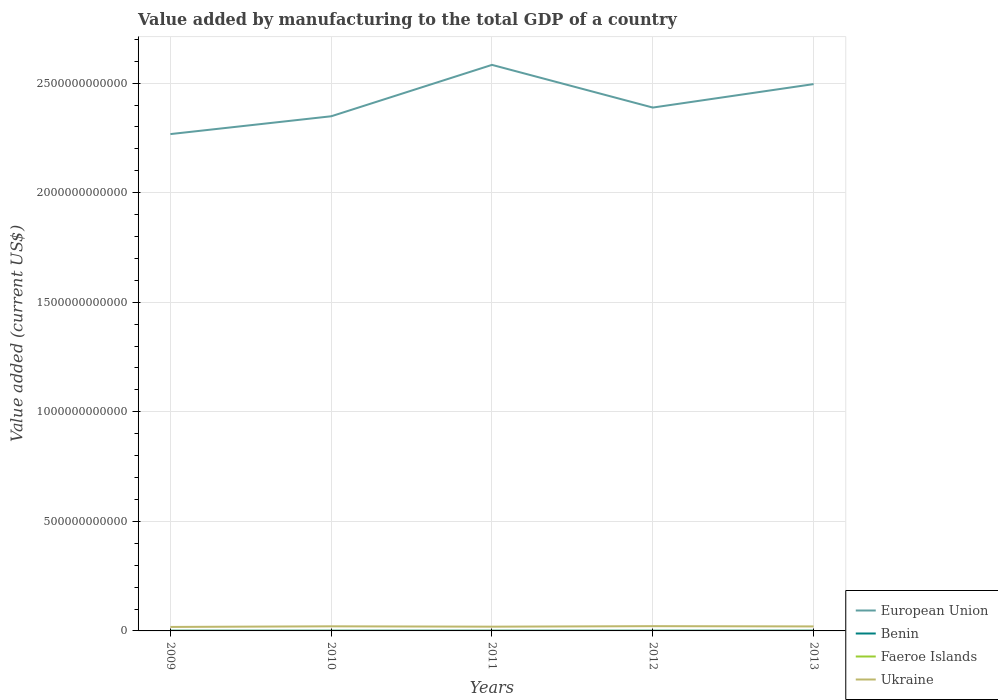How many different coloured lines are there?
Provide a succinct answer. 4. Does the line corresponding to Ukraine intersect with the line corresponding to European Union?
Provide a short and direct response. No. Across all years, what is the maximum value added by manufacturing to the total GDP in European Union?
Offer a terse response. 2.27e+12. What is the total value added by manufacturing to the total GDP in Ukraine in the graph?
Your response must be concise. -2.85e+09. What is the difference between the highest and the second highest value added by manufacturing to the total GDP in Ukraine?
Provide a short and direct response. 3.55e+09. What is the difference between the highest and the lowest value added by manufacturing to the total GDP in European Union?
Give a very brief answer. 2. Is the value added by manufacturing to the total GDP in Faeroe Islands strictly greater than the value added by manufacturing to the total GDP in Ukraine over the years?
Your response must be concise. Yes. How many lines are there?
Your answer should be compact. 4. What is the difference between two consecutive major ticks on the Y-axis?
Provide a short and direct response. 5.00e+11. Are the values on the major ticks of Y-axis written in scientific E-notation?
Make the answer very short. No. Does the graph contain grids?
Provide a succinct answer. Yes. How many legend labels are there?
Your answer should be compact. 4. How are the legend labels stacked?
Your answer should be very brief. Vertical. What is the title of the graph?
Make the answer very short. Value added by manufacturing to the total GDP of a country. Does "Congo (Democratic)" appear as one of the legend labels in the graph?
Give a very brief answer. No. What is the label or title of the Y-axis?
Keep it short and to the point. Value added (current US$). What is the Value added (current US$) in European Union in 2009?
Your answer should be compact. 2.27e+12. What is the Value added (current US$) in Benin in 2009?
Make the answer very short. 1.02e+09. What is the Value added (current US$) in Faeroe Islands in 2009?
Your response must be concise. 1.36e+08. What is the Value added (current US$) of Ukraine in 2009?
Your answer should be compact. 1.82e+1. What is the Value added (current US$) in European Union in 2010?
Provide a short and direct response. 2.35e+12. What is the Value added (current US$) in Benin in 2010?
Provide a short and direct response. 9.63e+08. What is the Value added (current US$) in Faeroe Islands in 2010?
Give a very brief answer. 1.35e+08. What is the Value added (current US$) of Ukraine in 2010?
Provide a short and direct response. 2.11e+1. What is the Value added (current US$) in European Union in 2011?
Your answer should be compact. 2.58e+12. What is the Value added (current US$) in Benin in 2011?
Provide a short and direct response. 1.04e+09. What is the Value added (current US$) in Faeroe Islands in 2011?
Provide a succinct answer. 1.44e+08. What is the Value added (current US$) in Ukraine in 2011?
Your answer should be very brief. 1.94e+1. What is the Value added (current US$) in European Union in 2012?
Keep it short and to the point. 2.39e+12. What is the Value added (current US$) in Benin in 2012?
Provide a short and direct response. 1.03e+09. What is the Value added (current US$) in Faeroe Islands in 2012?
Provide a succinct answer. 1.42e+08. What is the Value added (current US$) in Ukraine in 2012?
Offer a terse response. 2.18e+1. What is the Value added (current US$) in European Union in 2013?
Provide a short and direct response. 2.50e+12. What is the Value added (current US$) in Benin in 2013?
Offer a very short reply. 1.17e+09. What is the Value added (current US$) of Faeroe Islands in 2013?
Provide a short and direct response. 1.54e+08. What is the Value added (current US$) in Ukraine in 2013?
Provide a succinct answer. 2.06e+1. Across all years, what is the maximum Value added (current US$) of European Union?
Your answer should be compact. 2.58e+12. Across all years, what is the maximum Value added (current US$) in Benin?
Offer a terse response. 1.17e+09. Across all years, what is the maximum Value added (current US$) of Faeroe Islands?
Your response must be concise. 1.54e+08. Across all years, what is the maximum Value added (current US$) of Ukraine?
Your response must be concise. 2.18e+1. Across all years, what is the minimum Value added (current US$) of European Union?
Your answer should be very brief. 2.27e+12. Across all years, what is the minimum Value added (current US$) of Benin?
Your answer should be compact. 9.63e+08. Across all years, what is the minimum Value added (current US$) of Faeroe Islands?
Offer a terse response. 1.35e+08. Across all years, what is the minimum Value added (current US$) of Ukraine?
Provide a succinct answer. 1.82e+1. What is the total Value added (current US$) of European Union in the graph?
Your answer should be compact. 1.21e+13. What is the total Value added (current US$) in Benin in the graph?
Provide a succinct answer. 5.23e+09. What is the total Value added (current US$) in Faeroe Islands in the graph?
Offer a very short reply. 7.11e+08. What is the total Value added (current US$) in Ukraine in the graph?
Your answer should be very brief. 1.01e+11. What is the difference between the Value added (current US$) of European Union in 2009 and that in 2010?
Make the answer very short. -8.13e+1. What is the difference between the Value added (current US$) of Benin in 2009 and that in 2010?
Give a very brief answer. 6.15e+07. What is the difference between the Value added (current US$) in Faeroe Islands in 2009 and that in 2010?
Offer a terse response. 1.40e+06. What is the difference between the Value added (current US$) in Ukraine in 2009 and that in 2010?
Your response must be concise. -2.85e+09. What is the difference between the Value added (current US$) of European Union in 2009 and that in 2011?
Ensure brevity in your answer.  -3.16e+11. What is the difference between the Value added (current US$) of Benin in 2009 and that in 2011?
Ensure brevity in your answer.  -1.53e+07. What is the difference between the Value added (current US$) of Faeroe Islands in 2009 and that in 2011?
Give a very brief answer. -7.25e+06. What is the difference between the Value added (current US$) of Ukraine in 2009 and that in 2011?
Provide a short and direct response. -1.20e+09. What is the difference between the Value added (current US$) of European Union in 2009 and that in 2012?
Keep it short and to the point. -1.21e+11. What is the difference between the Value added (current US$) in Benin in 2009 and that in 2012?
Your answer should be very brief. -4.08e+05. What is the difference between the Value added (current US$) of Faeroe Islands in 2009 and that in 2012?
Your answer should be very brief. -6.07e+06. What is the difference between the Value added (current US$) in Ukraine in 2009 and that in 2012?
Give a very brief answer. -3.55e+09. What is the difference between the Value added (current US$) of European Union in 2009 and that in 2013?
Your response must be concise. -2.28e+11. What is the difference between the Value added (current US$) of Benin in 2009 and that in 2013?
Provide a short and direct response. -1.48e+08. What is the difference between the Value added (current US$) in Faeroe Islands in 2009 and that in 2013?
Your answer should be very brief. -1.73e+07. What is the difference between the Value added (current US$) of Ukraine in 2009 and that in 2013?
Give a very brief answer. -2.36e+09. What is the difference between the Value added (current US$) of European Union in 2010 and that in 2011?
Give a very brief answer. -2.35e+11. What is the difference between the Value added (current US$) of Benin in 2010 and that in 2011?
Ensure brevity in your answer.  -7.68e+07. What is the difference between the Value added (current US$) of Faeroe Islands in 2010 and that in 2011?
Offer a very short reply. -8.65e+06. What is the difference between the Value added (current US$) in Ukraine in 2010 and that in 2011?
Ensure brevity in your answer.  1.65e+09. What is the difference between the Value added (current US$) of European Union in 2010 and that in 2012?
Make the answer very short. -3.98e+1. What is the difference between the Value added (current US$) of Benin in 2010 and that in 2012?
Keep it short and to the point. -6.19e+07. What is the difference between the Value added (current US$) of Faeroe Islands in 2010 and that in 2012?
Provide a succinct answer. -7.47e+06. What is the difference between the Value added (current US$) of Ukraine in 2010 and that in 2012?
Keep it short and to the point. -7.00e+08. What is the difference between the Value added (current US$) in European Union in 2010 and that in 2013?
Offer a very short reply. -1.47e+11. What is the difference between the Value added (current US$) in Benin in 2010 and that in 2013?
Provide a short and direct response. -2.10e+08. What is the difference between the Value added (current US$) of Faeroe Islands in 2010 and that in 2013?
Offer a terse response. -1.87e+07. What is the difference between the Value added (current US$) of Ukraine in 2010 and that in 2013?
Offer a terse response. 4.96e+08. What is the difference between the Value added (current US$) of European Union in 2011 and that in 2012?
Provide a short and direct response. 1.95e+11. What is the difference between the Value added (current US$) in Benin in 2011 and that in 2012?
Your answer should be compact. 1.49e+07. What is the difference between the Value added (current US$) of Faeroe Islands in 2011 and that in 2012?
Offer a terse response. 1.18e+06. What is the difference between the Value added (current US$) of Ukraine in 2011 and that in 2012?
Offer a very short reply. -2.35e+09. What is the difference between the Value added (current US$) in European Union in 2011 and that in 2013?
Your answer should be very brief. 8.77e+1. What is the difference between the Value added (current US$) of Benin in 2011 and that in 2013?
Offer a terse response. -1.33e+08. What is the difference between the Value added (current US$) in Faeroe Islands in 2011 and that in 2013?
Your answer should be very brief. -1.00e+07. What is the difference between the Value added (current US$) in Ukraine in 2011 and that in 2013?
Your answer should be compact. -1.15e+09. What is the difference between the Value added (current US$) in European Union in 2012 and that in 2013?
Make the answer very short. -1.07e+11. What is the difference between the Value added (current US$) of Benin in 2012 and that in 2013?
Make the answer very short. -1.48e+08. What is the difference between the Value added (current US$) of Faeroe Islands in 2012 and that in 2013?
Provide a succinct answer. -1.12e+07. What is the difference between the Value added (current US$) of Ukraine in 2012 and that in 2013?
Give a very brief answer. 1.20e+09. What is the difference between the Value added (current US$) in European Union in 2009 and the Value added (current US$) in Benin in 2010?
Make the answer very short. 2.27e+12. What is the difference between the Value added (current US$) in European Union in 2009 and the Value added (current US$) in Faeroe Islands in 2010?
Provide a succinct answer. 2.27e+12. What is the difference between the Value added (current US$) of European Union in 2009 and the Value added (current US$) of Ukraine in 2010?
Give a very brief answer. 2.25e+12. What is the difference between the Value added (current US$) of Benin in 2009 and the Value added (current US$) of Faeroe Islands in 2010?
Ensure brevity in your answer.  8.90e+08. What is the difference between the Value added (current US$) of Benin in 2009 and the Value added (current US$) of Ukraine in 2010?
Provide a short and direct response. -2.00e+1. What is the difference between the Value added (current US$) in Faeroe Islands in 2009 and the Value added (current US$) in Ukraine in 2010?
Keep it short and to the point. -2.09e+1. What is the difference between the Value added (current US$) in European Union in 2009 and the Value added (current US$) in Benin in 2011?
Offer a terse response. 2.27e+12. What is the difference between the Value added (current US$) in European Union in 2009 and the Value added (current US$) in Faeroe Islands in 2011?
Offer a terse response. 2.27e+12. What is the difference between the Value added (current US$) in European Union in 2009 and the Value added (current US$) in Ukraine in 2011?
Make the answer very short. 2.25e+12. What is the difference between the Value added (current US$) in Benin in 2009 and the Value added (current US$) in Faeroe Islands in 2011?
Provide a succinct answer. 8.81e+08. What is the difference between the Value added (current US$) in Benin in 2009 and the Value added (current US$) in Ukraine in 2011?
Provide a succinct answer. -1.84e+1. What is the difference between the Value added (current US$) of Faeroe Islands in 2009 and the Value added (current US$) of Ukraine in 2011?
Make the answer very short. -1.93e+1. What is the difference between the Value added (current US$) in European Union in 2009 and the Value added (current US$) in Benin in 2012?
Your answer should be compact. 2.27e+12. What is the difference between the Value added (current US$) of European Union in 2009 and the Value added (current US$) of Faeroe Islands in 2012?
Ensure brevity in your answer.  2.27e+12. What is the difference between the Value added (current US$) of European Union in 2009 and the Value added (current US$) of Ukraine in 2012?
Provide a succinct answer. 2.25e+12. What is the difference between the Value added (current US$) of Benin in 2009 and the Value added (current US$) of Faeroe Islands in 2012?
Provide a succinct answer. 8.82e+08. What is the difference between the Value added (current US$) in Benin in 2009 and the Value added (current US$) in Ukraine in 2012?
Provide a succinct answer. -2.07e+1. What is the difference between the Value added (current US$) in Faeroe Islands in 2009 and the Value added (current US$) in Ukraine in 2012?
Provide a short and direct response. -2.16e+1. What is the difference between the Value added (current US$) of European Union in 2009 and the Value added (current US$) of Benin in 2013?
Make the answer very short. 2.27e+12. What is the difference between the Value added (current US$) of European Union in 2009 and the Value added (current US$) of Faeroe Islands in 2013?
Make the answer very short. 2.27e+12. What is the difference between the Value added (current US$) of European Union in 2009 and the Value added (current US$) of Ukraine in 2013?
Offer a terse response. 2.25e+12. What is the difference between the Value added (current US$) of Benin in 2009 and the Value added (current US$) of Faeroe Islands in 2013?
Your answer should be very brief. 8.71e+08. What is the difference between the Value added (current US$) in Benin in 2009 and the Value added (current US$) in Ukraine in 2013?
Your response must be concise. -1.95e+1. What is the difference between the Value added (current US$) in Faeroe Islands in 2009 and the Value added (current US$) in Ukraine in 2013?
Keep it short and to the point. -2.04e+1. What is the difference between the Value added (current US$) in European Union in 2010 and the Value added (current US$) in Benin in 2011?
Offer a terse response. 2.35e+12. What is the difference between the Value added (current US$) in European Union in 2010 and the Value added (current US$) in Faeroe Islands in 2011?
Keep it short and to the point. 2.35e+12. What is the difference between the Value added (current US$) in European Union in 2010 and the Value added (current US$) in Ukraine in 2011?
Give a very brief answer. 2.33e+12. What is the difference between the Value added (current US$) of Benin in 2010 and the Value added (current US$) of Faeroe Islands in 2011?
Provide a short and direct response. 8.20e+08. What is the difference between the Value added (current US$) in Benin in 2010 and the Value added (current US$) in Ukraine in 2011?
Offer a terse response. -1.84e+1. What is the difference between the Value added (current US$) of Faeroe Islands in 2010 and the Value added (current US$) of Ukraine in 2011?
Ensure brevity in your answer.  -1.93e+1. What is the difference between the Value added (current US$) of European Union in 2010 and the Value added (current US$) of Benin in 2012?
Ensure brevity in your answer.  2.35e+12. What is the difference between the Value added (current US$) in European Union in 2010 and the Value added (current US$) in Faeroe Islands in 2012?
Offer a very short reply. 2.35e+12. What is the difference between the Value added (current US$) in European Union in 2010 and the Value added (current US$) in Ukraine in 2012?
Ensure brevity in your answer.  2.33e+12. What is the difference between the Value added (current US$) in Benin in 2010 and the Value added (current US$) in Faeroe Islands in 2012?
Your answer should be very brief. 8.21e+08. What is the difference between the Value added (current US$) in Benin in 2010 and the Value added (current US$) in Ukraine in 2012?
Make the answer very short. -2.08e+1. What is the difference between the Value added (current US$) in Faeroe Islands in 2010 and the Value added (current US$) in Ukraine in 2012?
Ensure brevity in your answer.  -2.16e+1. What is the difference between the Value added (current US$) of European Union in 2010 and the Value added (current US$) of Benin in 2013?
Your answer should be very brief. 2.35e+12. What is the difference between the Value added (current US$) in European Union in 2010 and the Value added (current US$) in Faeroe Islands in 2013?
Provide a succinct answer. 2.35e+12. What is the difference between the Value added (current US$) of European Union in 2010 and the Value added (current US$) of Ukraine in 2013?
Offer a terse response. 2.33e+12. What is the difference between the Value added (current US$) in Benin in 2010 and the Value added (current US$) in Faeroe Islands in 2013?
Offer a very short reply. 8.10e+08. What is the difference between the Value added (current US$) of Benin in 2010 and the Value added (current US$) of Ukraine in 2013?
Provide a succinct answer. -1.96e+1. What is the difference between the Value added (current US$) in Faeroe Islands in 2010 and the Value added (current US$) in Ukraine in 2013?
Provide a short and direct response. -2.04e+1. What is the difference between the Value added (current US$) of European Union in 2011 and the Value added (current US$) of Benin in 2012?
Provide a short and direct response. 2.58e+12. What is the difference between the Value added (current US$) in European Union in 2011 and the Value added (current US$) in Faeroe Islands in 2012?
Provide a short and direct response. 2.58e+12. What is the difference between the Value added (current US$) in European Union in 2011 and the Value added (current US$) in Ukraine in 2012?
Provide a short and direct response. 2.56e+12. What is the difference between the Value added (current US$) in Benin in 2011 and the Value added (current US$) in Faeroe Islands in 2012?
Provide a succinct answer. 8.98e+08. What is the difference between the Value added (current US$) of Benin in 2011 and the Value added (current US$) of Ukraine in 2012?
Make the answer very short. -2.07e+1. What is the difference between the Value added (current US$) of Faeroe Islands in 2011 and the Value added (current US$) of Ukraine in 2012?
Ensure brevity in your answer.  -2.16e+1. What is the difference between the Value added (current US$) in European Union in 2011 and the Value added (current US$) in Benin in 2013?
Provide a succinct answer. 2.58e+12. What is the difference between the Value added (current US$) of European Union in 2011 and the Value added (current US$) of Faeroe Islands in 2013?
Make the answer very short. 2.58e+12. What is the difference between the Value added (current US$) in European Union in 2011 and the Value added (current US$) in Ukraine in 2013?
Offer a terse response. 2.56e+12. What is the difference between the Value added (current US$) of Benin in 2011 and the Value added (current US$) of Faeroe Islands in 2013?
Your answer should be very brief. 8.86e+08. What is the difference between the Value added (current US$) of Benin in 2011 and the Value added (current US$) of Ukraine in 2013?
Your answer should be compact. -1.95e+1. What is the difference between the Value added (current US$) in Faeroe Islands in 2011 and the Value added (current US$) in Ukraine in 2013?
Offer a terse response. -2.04e+1. What is the difference between the Value added (current US$) in European Union in 2012 and the Value added (current US$) in Benin in 2013?
Give a very brief answer. 2.39e+12. What is the difference between the Value added (current US$) in European Union in 2012 and the Value added (current US$) in Faeroe Islands in 2013?
Make the answer very short. 2.39e+12. What is the difference between the Value added (current US$) in European Union in 2012 and the Value added (current US$) in Ukraine in 2013?
Ensure brevity in your answer.  2.37e+12. What is the difference between the Value added (current US$) in Benin in 2012 and the Value added (current US$) in Faeroe Islands in 2013?
Give a very brief answer. 8.72e+08. What is the difference between the Value added (current US$) of Benin in 2012 and the Value added (current US$) of Ukraine in 2013?
Offer a terse response. -1.95e+1. What is the difference between the Value added (current US$) in Faeroe Islands in 2012 and the Value added (current US$) in Ukraine in 2013?
Give a very brief answer. -2.04e+1. What is the average Value added (current US$) in European Union per year?
Provide a short and direct response. 2.42e+12. What is the average Value added (current US$) in Benin per year?
Keep it short and to the point. 1.05e+09. What is the average Value added (current US$) in Faeroe Islands per year?
Make the answer very short. 1.42e+08. What is the average Value added (current US$) in Ukraine per year?
Your answer should be very brief. 2.02e+1. In the year 2009, what is the difference between the Value added (current US$) in European Union and Value added (current US$) in Benin?
Make the answer very short. 2.27e+12. In the year 2009, what is the difference between the Value added (current US$) of European Union and Value added (current US$) of Faeroe Islands?
Offer a very short reply. 2.27e+12. In the year 2009, what is the difference between the Value added (current US$) of European Union and Value added (current US$) of Ukraine?
Provide a short and direct response. 2.25e+12. In the year 2009, what is the difference between the Value added (current US$) of Benin and Value added (current US$) of Faeroe Islands?
Give a very brief answer. 8.88e+08. In the year 2009, what is the difference between the Value added (current US$) of Benin and Value added (current US$) of Ukraine?
Offer a terse response. -1.72e+1. In the year 2009, what is the difference between the Value added (current US$) of Faeroe Islands and Value added (current US$) of Ukraine?
Give a very brief answer. -1.81e+1. In the year 2010, what is the difference between the Value added (current US$) in European Union and Value added (current US$) in Benin?
Keep it short and to the point. 2.35e+12. In the year 2010, what is the difference between the Value added (current US$) in European Union and Value added (current US$) in Faeroe Islands?
Offer a terse response. 2.35e+12. In the year 2010, what is the difference between the Value added (current US$) in European Union and Value added (current US$) in Ukraine?
Give a very brief answer. 2.33e+12. In the year 2010, what is the difference between the Value added (current US$) in Benin and Value added (current US$) in Faeroe Islands?
Give a very brief answer. 8.28e+08. In the year 2010, what is the difference between the Value added (current US$) in Benin and Value added (current US$) in Ukraine?
Make the answer very short. -2.01e+1. In the year 2010, what is the difference between the Value added (current US$) in Faeroe Islands and Value added (current US$) in Ukraine?
Your answer should be very brief. -2.09e+1. In the year 2011, what is the difference between the Value added (current US$) of European Union and Value added (current US$) of Benin?
Give a very brief answer. 2.58e+12. In the year 2011, what is the difference between the Value added (current US$) of European Union and Value added (current US$) of Faeroe Islands?
Make the answer very short. 2.58e+12. In the year 2011, what is the difference between the Value added (current US$) in European Union and Value added (current US$) in Ukraine?
Keep it short and to the point. 2.56e+12. In the year 2011, what is the difference between the Value added (current US$) in Benin and Value added (current US$) in Faeroe Islands?
Make the answer very short. 8.97e+08. In the year 2011, what is the difference between the Value added (current US$) in Benin and Value added (current US$) in Ukraine?
Offer a terse response. -1.84e+1. In the year 2011, what is the difference between the Value added (current US$) of Faeroe Islands and Value added (current US$) of Ukraine?
Your answer should be very brief. -1.93e+1. In the year 2012, what is the difference between the Value added (current US$) in European Union and Value added (current US$) in Benin?
Provide a short and direct response. 2.39e+12. In the year 2012, what is the difference between the Value added (current US$) in European Union and Value added (current US$) in Faeroe Islands?
Keep it short and to the point. 2.39e+12. In the year 2012, what is the difference between the Value added (current US$) of European Union and Value added (current US$) of Ukraine?
Keep it short and to the point. 2.37e+12. In the year 2012, what is the difference between the Value added (current US$) in Benin and Value added (current US$) in Faeroe Islands?
Offer a very short reply. 8.83e+08. In the year 2012, what is the difference between the Value added (current US$) of Benin and Value added (current US$) of Ukraine?
Ensure brevity in your answer.  -2.07e+1. In the year 2012, what is the difference between the Value added (current US$) in Faeroe Islands and Value added (current US$) in Ukraine?
Offer a terse response. -2.16e+1. In the year 2013, what is the difference between the Value added (current US$) in European Union and Value added (current US$) in Benin?
Make the answer very short. 2.49e+12. In the year 2013, what is the difference between the Value added (current US$) of European Union and Value added (current US$) of Faeroe Islands?
Provide a succinct answer. 2.50e+12. In the year 2013, what is the difference between the Value added (current US$) in European Union and Value added (current US$) in Ukraine?
Offer a terse response. 2.48e+12. In the year 2013, what is the difference between the Value added (current US$) in Benin and Value added (current US$) in Faeroe Islands?
Ensure brevity in your answer.  1.02e+09. In the year 2013, what is the difference between the Value added (current US$) in Benin and Value added (current US$) in Ukraine?
Your answer should be compact. -1.94e+1. In the year 2013, what is the difference between the Value added (current US$) in Faeroe Islands and Value added (current US$) in Ukraine?
Provide a succinct answer. -2.04e+1. What is the ratio of the Value added (current US$) of European Union in 2009 to that in 2010?
Your answer should be compact. 0.97. What is the ratio of the Value added (current US$) in Benin in 2009 to that in 2010?
Your answer should be compact. 1.06. What is the ratio of the Value added (current US$) in Faeroe Islands in 2009 to that in 2010?
Your answer should be compact. 1.01. What is the ratio of the Value added (current US$) of Ukraine in 2009 to that in 2010?
Your response must be concise. 0.86. What is the ratio of the Value added (current US$) of European Union in 2009 to that in 2011?
Ensure brevity in your answer.  0.88. What is the ratio of the Value added (current US$) of Benin in 2009 to that in 2011?
Make the answer very short. 0.99. What is the ratio of the Value added (current US$) of Faeroe Islands in 2009 to that in 2011?
Your answer should be compact. 0.95. What is the ratio of the Value added (current US$) of Ukraine in 2009 to that in 2011?
Provide a succinct answer. 0.94. What is the ratio of the Value added (current US$) in European Union in 2009 to that in 2012?
Make the answer very short. 0.95. What is the ratio of the Value added (current US$) in Faeroe Islands in 2009 to that in 2012?
Make the answer very short. 0.96. What is the ratio of the Value added (current US$) of Ukraine in 2009 to that in 2012?
Ensure brevity in your answer.  0.84. What is the ratio of the Value added (current US$) in European Union in 2009 to that in 2013?
Keep it short and to the point. 0.91. What is the ratio of the Value added (current US$) of Benin in 2009 to that in 2013?
Your response must be concise. 0.87. What is the ratio of the Value added (current US$) of Faeroe Islands in 2009 to that in 2013?
Your answer should be very brief. 0.89. What is the ratio of the Value added (current US$) in Ukraine in 2009 to that in 2013?
Offer a very short reply. 0.89. What is the ratio of the Value added (current US$) in European Union in 2010 to that in 2011?
Offer a very short reply. 0.91. What is the ratio of the Value added (current US$) in Benin in 2010 to that in 2011?
Make the answer very short. 0.93. What is the ratio of the Value added (current US$) in Faeroe Islands in 2010 to that in 2011?
Your answer should be very brief. 0.94. What is the ratio of the Value added (current US$) in Ukraine in 2010 to that in 2011?
Keep it short and to the point. 1.08. What is the ratio of the Value added (current US$) in European Union in 2010 to that in 2012?
Your answer should be compact. 0.98. What is the ratio of the Value added (current US$) in Benin in 2010 to that in 2012?
Keep it short and to the point. 0.94. What is the ratio of the Value added (current US$) in Faeroe Islands in 2010 to that in 2012?
Provide a succinct answer. 0.95. What is the ratio of the Value added (current US$) in Ukraine in 2010 to that in 2012?
Ensure brevity in your answer.  0.97. What is the ratio of the Value added (current US$) in Benin in 2010 to that in 2013?
Your answer should be very brief. 0.82. What is the ratio of the Value added (current US$) of Faeroe Islands in 2010 to that in 2013?
Make the answer very short. 0.88. What is the ratio of the Value added (current US$) of Ukraine in 2010 to that in 2013?
Your answer should be compact. 1.02. What is the ratio of the Value added (current US$) in European Union in 2011 to that in 2012?
Make the answer very short. 1.08. What is the ratio of the Value added (current US$) of Benin in 2011 to that in 2012?
Your answer should be very brief. 1.01. What is the ratio of the Value added (current US$) in Faeroe Islands in 2011 to that in 2012?
Offer a very short reply. 1.01. What is the ratio of the Value added (current US$) of Ukraine in 2011 to that in 2012?
Offer a terse response. 0.89. What is the ratio of the Value added (current US$) in European Union in 2011 to that in 2013?
Your response must be concise. 1.04. What is the ratio of the Value added (current US$) of Benin in 2011 to that in 2013?
Make the answer very short. 0.89. What is the ratio of the Value added (current US$) in Faeroe Islands in 2011 to that in 2013?
Keep it short and to the point. 0.93. What is the ratio of the Value added (current US$) of Ukraine in 2011 to that in 2013?
Ensure brevity in your answer.  0.94. What is the ratio of the Value added (current US$) in European Union in 2012 to that in 2013?
Provide a succinct answer. 0.96. What is the ratio of the Value added (current US$) in Benin in 2012 to that in 2013?
Give a very brief answer. 0.87. What is the ratio of the Value added (current US$) in Faeroe Islands in 2012 to that in 2013?
Your answer should be compact. 0.93. What is the ratio of the Value added (current US$) of Ukraine in 2012 to that in 2013?
Your answer should be very brief. 1.06. What is the difference between the highest and the second highest Value added (current US$) of European Union?
Ensure brevity in your answer.  8.77e+1. What is the difference between the highest and the second highest Value added (current US$) in Benin?
Your answer should be compact. 1.33e+08. What is the difference between the highest and the second highest Value added (current US$) of Faeroe Islands?
Provide a succinct answer. 1.00e+07. What is the difference between the highest and the second highest Value added (current US$) of Ukraine?
Offer a terse response. 7.00e+08. What is the difference between the highest and the lowest Value added (current US$) of European Union?
Your response must be concise. 3.16e+11. What is the difference between the highest and the lowest Value added (current US$) of Benin?
Your answer should be very brief. 2.10e+08. What is the difference between the highest and the lowest Value added (current US$) in Faeroe Islands?
Your answer should be compact. 1.87e+07. What is the difference between the highest and the lowest Value added (current US$) of Ukraine?
Your answer should be compact. 3.55e+09. 